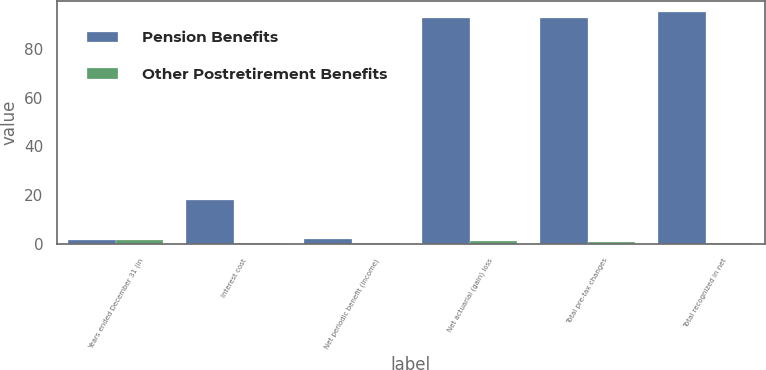Convert chart. <chart><loc_0><loc_0><loc_500><loc_500><stacked_bar_chart><ecel><fcel>Years ended December 31 (in<fcel>Interest cost<fcel>Net periodic benefit (income)<fcel>Net actuarial (gain) loss<fcel>Total pre-tax changes<fcel>Total recognized in net<nl><fcel>Pension Benefits<fcel>1.8<fcel>17.9<fcel>2.3<fcel>92.6<fcel>92.6<fcel>94.9<nl><fcel>Other Postretirement Benefits<fcel>1.8<fcel>0.5<fcel>0.5<fcel>1.3<fcel>1.1<fcel>0.6<nl></chart> 